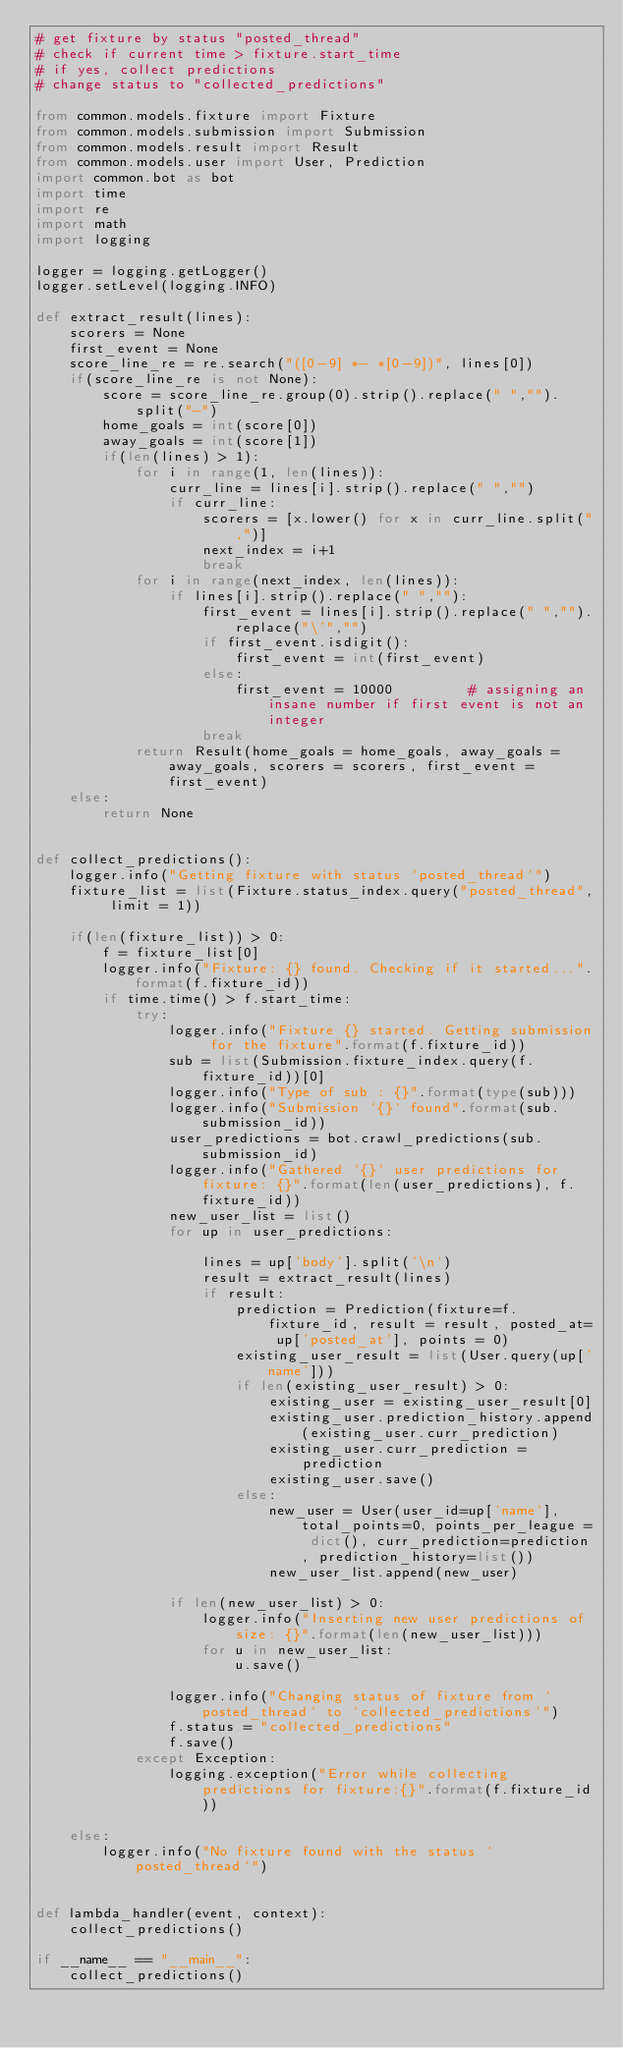Convert code to text. <code><loc_0><loc_0><loc_500><loc_500><_Python_># get fixture by status "posted_thread"
# check if current time > fixture.start_time
# if yes, collect predictions
# change status to "collected_predictions"

from common.models.fixture import Fixture
from common.models.submission import Submission
from common.models.result import Result
from common.models.user import User, Prediction
import common.bot as bot
import time
import re
import math
import logging

logger = logging.getLogger()
logger.setLevel(logging.INFO)

def extract_result(lines):
    scorers = None
    first_event = None
    score_line_re = re.search("([0-9] *- *[0-9])", lines[0])
    if(score_line_re is not None):
        score = score_line_re.group(0).strip().replace(" ","").split("-")
        home_goals = int(score[0])
        away_goals = int(score[1])
        if(len(lines) > 1):
            for i in range(1, len(lines)):
                curr_line = lines[i].strip().replace(" ","")
                if curr_line:
                    scorers = [x.lower() for x in curr_line.split(",")]
                    next_index = i+1
                    break
            for i in range(next_index, len(lines)):
                if lines[i].strip().replace(" ",""):
                    first_event = lines[i].strip().replace(" ","").replace("\'","")
                    if first_event.isdigit():
                        first_event = int(first_event)
                    else:
                        first_event = 10000         # assigning an insane number if first event is not an integer
                    break
            return Result(home_goals = home_goals, away_goals = away_goals, scorers = scorers, first_event = first_event)
    else:
        return None


def collect_predictions():
    logger.info("Getting fixture with status `posted_thread`")
    fixture_list = list(Fixture.status_index.query("posted_thread", limit = 1))

    if(len(fixture_list)) > 0:
        f = fixture_list[0]
        logger.info("Fixture: {} found. Checking if it started...".format(f.fixture_id))
        if time.time() > f.start_time:
            try:
                logger.info("Fixture {} started. Getting submission for the fixture".format(f.fixture_id))
                sub = list(Submission.fixture_index.query(f.fixture_id))[0]
                logger.info("Type of sub : {}".format(type(sub)))
                logger.info("Submission `{}` found".format(sub.submission_id))
                user_predictions = bot.crawl_predictions(sub.submission_id)
                logger.info("Gathered `{}` user predictions for fixture: {}".format(len(user_predictions), f.fixture_id))
                new_user_list = list()
                for up in user_predictions:
                    
                    lines = up['body'].split('\n')
                    result = extract_result(lines)
                    if result:
                        prediction = Prediction(fixture=f.fixture_id, result = result, posted_at= up['posted_at'], points = 0)
                        existing_user_result = list(User.query(up['name']))
                        if len(existing_user_result) > 0:
                            existing_user = existing_user_result[0]
                            existing_user.prediction_history.append(existing_user.curr_prediction)
                            existing_user.curr_prediction = prediction
                            existing_user.save()
                        else:
                            new_user = User(user_id=up['name'], total_points=0, points_per_league = dict(), curr_prediction=prediction, prediction_history=list())
                            new_user_list.append(new_user)
                        
                if len(new_user_list) > 0:
                    logger.info("Inserting new user predictions of size: {}".format(len(new_user_list)))
                    for u in new_user_list:
                        u.save()
                        
                logger.info("Changing status of fixture from `posted_thread` to `collected_predictions`")
                f.status = "collected_predictions"
                f.save()
            except Exception:
                logging.exception("Error while collecting predictions for fixture:{}".format(f.fixture_id))

    else:
        logger.info("No fixture found with the status `posted_thread`")


def lambda_handler(event, context):
    collect_predictions()

if __name__ == "__main__":
    collect_predictions()</code> 